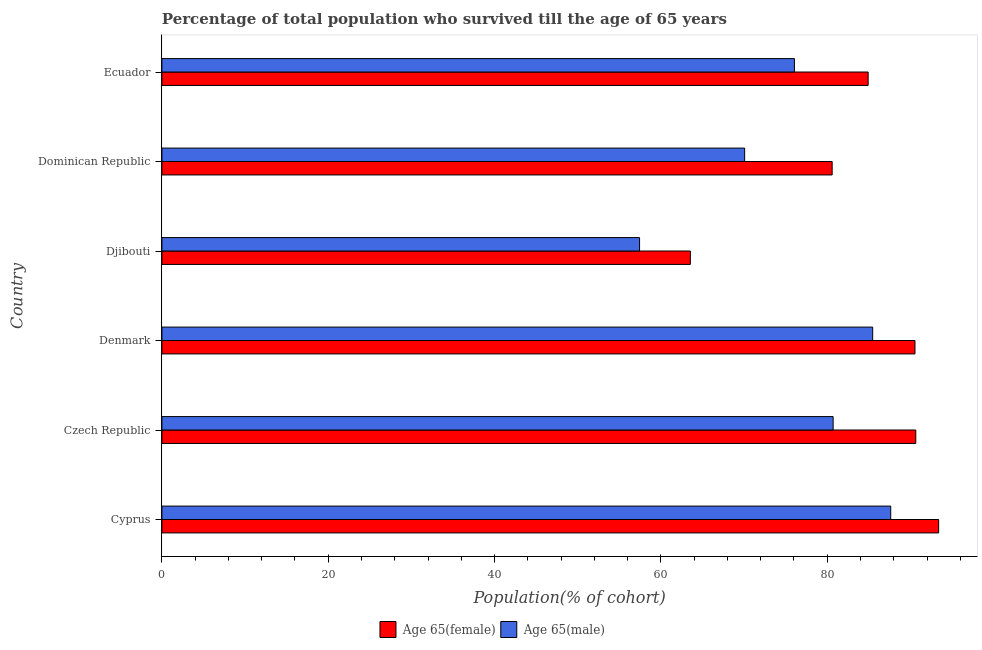How many groups of bars are there?
Provide a short and direct response. 6. Are the number of bars on each tick of the Y-axis equal?
Make the answer very short. Yes. How many bars are there on the 2nd tick from the bottom?
Your answer should be compact. 2. What is the label of the 3rd group of bars from the top?
Offer a terse response. Djibouti. In how many cases, is the number of bars for a given country not equal to the number of legend labels?
Provide a succinct answer. 0. What is the percentage of male population who survived till age of 65 in Czech Republic?
Ensure brevity in your answer.  80.71. Across all countries, what is the maximum percentage of male population who survived till age of 65?
Your answer should be very brief. 87.63. Across all countries, what is the minimum percentage of male population who survived till age of 65?
Your response must be concise. 57.43. In which country was the percentage of female population who survived till age of 65 maximum?
Offer a very short reply. Cyprus. In which country was the percentage of female population who survived till age of 65 minimum?
Your response must be concise. Djibouti. What is the total percentage of male population who survived till age of 65 in the graph?
Give a very brief answer. 457.36. What is the difference between the percentage of female population who survived till age of 65 in Cyprus and that in Dominican Republic?
Give a very brief answer. 12.8. What is the difference between the percentage of male population who survived till age of 65 in Cyprus and the percentage of female population who survived till age of 65 in Djibouti?
Provide a succinct answer. 24.09. What is the average percentage of male population who survived till age of 65 per country?
Your response must be concise. 76.23. What is the difference between the percentage of male population who survived till age of 65 and percentage of female population who survived till age of 65 in Cyprus?
Keep it short and to the point. -5.76. In how many countries, is the percentage of female population who survived till age of 65 greater than 72 %?
Give a very brief answer. 5. What is the ratio of the percentage of male population who survived till age of 65 in Cyprus to that in Dominican Republic?
Your response must be concise. 1.25. What is the difference between the highest and the second highest percentage of female population who survived till age of 65?
Your answer should be very brief. 2.75. What is the difference between the highest and the lowest percentage of male population who survived till age of 65?
Your answer should be very brief. 30.2. In how many countries, is the percentage of female population who survived till age of 65 greater than the average percentage of female population who survived till age of 65 taken over all countries?
Offer a terse response. 4. Is the sum of the percentage of female population who survived till age of 65 in Czech Republic and Dominican Republic greater than the maximum percentage of male population who survived till age of 65 across all countries?
Offer a very short reply. Yes. What does the 1st bar from the top in Ecuador represents?
Offer a terse response. Age 65(male). What does the 1st bar from the bottom in Cyprus represents?
Give a very brief answer. Age 65(female). How many bars are there?
Offer a terse response. 12. Does the graph contain any zero values?
Provide a short and direct response. No. What is the title of the graph?
Ensure brevity in your answer.  Percentage of total population who survived till the age of 65 years. Does "Commercial service imports" appear as one of the legend labels in the graph?
Make the answer very short. No. What is the label or title of the X-axis?
Keep it short and to the point. Population(% of cohort). What is the label or title of the Y-axis?
Your answer should be very brief. Country. What is the Population(% of cohort) of Age 65(female) in Cyprus?
Provide a short and direct response. 93.4. What is the Population(% of cohort) in Age 65(male) in Cyprus?
Offer a terse response. 87.63. What is the Population(% of cohort) in Age 65(female) in Czech Republic?
Your answer should be very brief. 90.65. What is the Population(% of cohort) of Age 65(male) in Czech Republic?
Make the answer very short. 80.71. What is the Population(% of cohort) in Age 65(female) in Denmark?
Provide a short and direct response. 90.55. What is the Population(% of cohort) of Age 65(male) in Denmark?
Keep it short and to the point. 85.46. What is the Population(% of cohort) in Age 65(female) in Djibouti?
Offer a terse response. 63.54. What is the Population(% of cohort) in Age 65(male) in Djibouti?
Ensure brevity in your answer.  57.43. What is the Population(% of cohort) in Age 65(female) in Dominican Republic?
Ensure brevity in your answer.  80.59. What is the Population(% of cohort) in Age 65(male) in Dominican Republic?
Your answer should be very brief. 70.07. What is the Population(% of cohort) in Age 65(female) in Ecuador?
Give a very brief answer. 84.92. What is the Population(% of cohort) of Age 65(male) in Ecuador?
Your answer should be compact. 76.05. Across all countries, what is the maximum Population(% of cohort) in Age 65(female)?
Your answer should be very brief. 93.4. Across all countries, what is the maximum Population(% of cohort) of Age 65(male)?
Your response must be concise. 87.63. Across all countries, what is the minimum Population(% of cohort) in Age 65(female)?
Keep it short and to the point. 63.54. Across all countries, what is the minimum Population(% of cohort) of Age 65(male)?
Offer a very short reply. 57.43. What is the total Population(% of cohort) of Age 65(female) in the graph?
Provide a short and direct response. 503.64. What is the total Population(% of cohort) in Age 65(male) in the graph?
Give a very brief answer. 457.36. What is the difference between the Population(% of cohort) of Age 65(female) in Cyprus and that in Czech Republic?
Provide a succinct answer. 2.75. What is the difference between the Population(% of cohort) of Age 65(male) in Cyprus and that in Czech Republic?
Ensure brevity in your answer.  6.92. What is the difference between the Population(% of cohort) in Age 65(female) in Cyprus and that in Denmark?
Your response must be concise. 2.85. What is the difference between the Population(% of cohort) of Age 65(male) in Cyprus and that in Denmark?
Make the answer very short. 2.17. What is the difference between the Population(% of cohort) of Age 65(female) in Cyprus and that in Djibouti?
Provide a succinct answer. 29.86. What is the difference between the Population(% of cohort) of Age 65(male) in Cyprus and that in Djibouti?
Ensure brevity in your answer.  30.2. What is the difference between the Population(% of cohort) in Age 65(female) in Cyprus and that in Dominican Republic?
Your answer should be compact. 12.8. What is the difference between the Population(% of cohort) of Age 65(male) in Cyprus and that in Dominican Republic?
Offer a terse response. 17.56. What is the difference between the Population(% of cohort) of Age 65(female) in Cyprus and that in Ecuador?
Provide a succinct answer. 8.48. What is the difference between the Population(% of cohort) of Age 65(male) in Cyprus and that in Ecuador?
Provide a succinct answer. 11.58. What is the difference between the Population(% of cohort) of Age 65(female) in Czech Republic and that in Denmark?
Offer a very short reply. 0.1. What is the difference between the Population(% of cohort) in Age 65(male) in Czech Republic and that in Denmark?
Give a very brief answer. -4.76. What is the difference between the Population(% of cohort) in Age 65(female) in Czech Republic and that in Djibouti?
Provide a succinct answer. 27.11. What is the difference between the Population(% of cohort) in Age 65(male) in Czech Republic and that in Djibouti?
Your response must be concise. 23.27. What is the difference between the Population(% of cohort) of Age 65(female) in Czech Republic and that in Dominican Republic?
Offer a very short reply. 10.05. What is the difference between the Population(% of cohort) of Age 65(male) in Czech Republic and that in Dominican Republic?
Your response must be concise. 10.64. What is the difference between the Population(% of cohort) of Age 65(female) in Czech Republic and that in Ecuador?
Provide a short and direct response. 5.73. What is the difference between the Population(% of cohort) of Age 65(male) in Czech Republic and that in Ecuador?
Keep it short and to the point. 4.66. What is the difference between the Population(% of cohort) in Age 65(female) in Denmark and that in Djibouti?
Offer a very short reply. 27.01. What is the difference between the Population(% of cohort) in Age 65(male) in Denmark and that in Djibouti?
Ensure brevity in your answer.  28.03. What is the difference between the Population(% of cohort) in Age 65(female) in Denmark and that in Dominican Republic?
Offer a very short reply. 9.96. What is the difference between the Population(% of cohort) in Age 65(male) in Denmark and that in Dominican Republic?
Offer a very short reply. 15.4. What is the difference between the Population(% of cohort) of Age 65(female) in Denmark and that in Ecuador?
Keep it short and to the point. 5.63. What is the difference between the Population(% of cohort) of Age 65(male) in Denmark and that in Ecuador?
Your answer should be very brief. 9.41. What is the difference between the Population(% of cohort) of Age 65(female) in Djibouti and that in Dominican Republic?
Your answer should be compact. -17.05. What is the difference between the Population(% of cohort) of Age 65(male) in Djibouti and that in Dominican Republic?
Offer a very short reply. -12.63. What is the difference between the Population(% of cohort) of Age 65(female) in Djibouti and that in Ecuador?
Your answer should be very brief. -21.38. What is the difference between the Population(% of cohort) in Age 65(male) in Djibouti and that in Ecuador?
Your answer should be very brief. -18.62. What is the difference between the Population(% of cohort) in Age 65(female) in Dominican Republic and that in Ecuador?
Keep it short and to the point. -4.33. What is the difference between the Population(% of cohort) in Age 65(male) in Dominican Republic and that in Ecuador?
Offer a terse response. -5.98. What is the difference between the Population(% of cohort) in Age 65(female) in Cyprus and the Population(% of cohort) in Age 65(male) in Czech Republic?
Offer a terse response. 12.69. What is the difference between the Population(% of cohort) in Age 65(female) in Cyprus and the Population(% of cohort) in Age 65(male) in Denmark?
Offer a very short reply. 7.93. What is the difference between the Population(% of cohort) of Age 65(female) in Cyprus and the Population(% of cohort) of Age 65(male) in Djibouti?
Provide a succinct answer. 35.96. What is the difference between the Population(% of cohort) of Age 65(female) in Cyprus and the Population(% of cohort) of Age 65(male) in Dominican Republic?
Offer a very short reply. 23.33. What is the difference between the Population(% of cohort) in Age 65(female) in Cyprus and the Population(% of cohort) in Age 65(male) in Ecuador?
Make the answer very short. 17.34. What is the difference between the Population(% of cohort) in Age 65(female) in Czech Republic and the Population(% of cohort) in Age 65(male) in Denmark?
Provide a short and direct response. 5.18. What is the difference between the Population(% of cohort) in Age 65(female) in Czech Republic and the Population(% of cohort) in Age 65(male) in Djibouti?
Your answer should be very brief. 33.21. What is the difference between the Population(% of cohort) in Age 65(female) in Czech Republic and the Population(% of cohort) in Age 65(male) in Dominican Republic?
Provide a short and direct response. 20.58. What is the difference between the Population(% of cohort) of Age 65(female) in Czech Republic and the Population(% of cohort) of Age 65(male) in Ecuador?
Provide a succinct answer. 14.59. What is the difference between the Population(% of cohort) in Age 65(female) in Denmark and the Population(% of cohort) in Age 65(male) in Djibouti?
Provide a succinct answer. 33.12. What is the difference between the Population(% of cohort) in Age 65(female) in Denmark and the Population(% of cohort) in Age 65(male) in Dominican Republic?
Your response must be concise. 20.48. What is the difference between the Population(% of cohort) of Age 65(female) in Denmark and the Population(% of cohort) of Age 65(male) in Ecuador?
Offer a very short reply. 14.5. What is the difference between the Population(% of cohort) in Age 65(female) in Djibouti and the Population(% of cohort) in Age 65(male) in Dominican Republic?
Offer a very short reply. -6.53. What is the difference between the Population(% of cohort) of Age 65(female) in Djibouti and the Population(% of cohort) of Age 65(male) in Ecuador?
Offer a terse response. -12.51. What is the difference between the Population(% of cohort) of Age 65(female) in Dominican Republic and the Population(% of cohort) of Age 65(male) in Ecuador?
Offer a very short reply. 4.54. What is the average Population(% of cohort) of Age 65(female) per country?
Your answer should be compact. 83.94. What is the average Population(% of cohort) of Age 65(male) per country?
Make the answer very short. 76.23. What is the difference between the Population(% of cohort) in Age 65(female) and Population(% of cohort) in Age 65(male) in Cyprus?
Offer a very short reply. 5.76. What is the difference between the Population(% of cohort) of Age 65(female) and Population(% of cohort) of Age 65(male) in Czech Republic?
Make the answer very short. 9.94. What is the difference between the Population(% of cohort) in Age 65(female) and Population(% of cohort) in Age 65(male) in Denmark?
Give a very brief answer. 5.09. What is the difference between the Population(% of cohort) of Age 65(female) and Population(% of cohort) of Age 65(male) in Djibouti?
Your response must be concise. 6.11. What is the difference between the Population(% of cohort) of Age 65(female) and Population(% of cohort) of Age 65(male) in Dominican Republic?
Provide a succinct answer. 10.52. What is the difference between the Population(% of cohort) of Age 65(female) and Population(% of cohort) of Age 65(male) in Ecuador?
Ensure brevity in your answer.  8.86. What is the ratio of the Population(% of cohort) of Age 65(female) in Cyprus to that in Czech Republic?
Your response must be concise. 1.03. What is the ratio of the Population(% of cohort) of Age 65(male) in Cyprus to that in Czech Republic?
Offer a very short reply. 1.09. What is the ratio of the Population(% of cohort) in Age 65(female) in Cyprus to that in Denmark?
Offer a very short reply. 1.03. What is the ratio of the Population(% of cohort) in Age 65(male) in Cyprus to that in Denmark?
Your response must be concise. 1.03. What is the ratio of the Population(% of cohort) of Age 65(female) in Cyprus to that in Djibouti?
Provide a short and direct response. 1.47. What is the ratio of the Population(% of cohort) in Age 65(male) in Cyprus to that in Djibouti?
Your answer should be compact. 1.53. What is the ratio of the Population(% of cohort) in Age 65(female) in Cyprus to that in Dominican Republic?
Your answer should be very brief. 1.16. What is the ratio of the Population(% of cohort) in Age 65(male) in Cyprus to that in Dominican Republic?
Keep it short and to the point. 1.25. What is the ratio of the Population(% of cohort) in Age 65(female) in Cyprus to that in Ecuador?
Keep it short and to the point. 1.1. What is the ratio of the Population(% of cohort) in Age 65(male) in Cyprus to that in Ecuador?
Your answer should be compact. 1.15. What is the ratio of the Population(% of cohort) in Age 65(female) in Czech Republic to that in Denmark?
Your response must be concise. 1. What is the ratio of the Population(% of cohort) of Age 65(female) in Czech Republic to that in Djibouti?
Keep it short and to the point. 1.43. What is the ratio of the Population(% of cohort) of Age 65(male) in Czech Republic to that in Djibouti?
Your response must be concise. 1.41. What is the ratio of the Population(% of cohort) in Age 65(female) in Czech Republic to that in Dominican Republic?
Offer a terse response. 1.12. What is the ratio of the Population(% of cohort) in Age 65(male) in Czech Republic to that in Dominican Republic?
Your response must be concise. 1.15. What is the ratio of the Population(% of cohort) of Age 65(female) in Czech Republic to that in Ecuador?
Offer a terse response. 1.07. What is the ratio of the Population(% of cohort) in Age 65(male) in Czech Republic to that in Ecuador?
Offer a terse response. 1.06. What is the ratio of the Population(% of cohort) of Age 65(female) in Denmark to that in Djibouti?
Your answer should be compact. 1.43. What is the ratio of the Population(% of cohort) of Age 65(male) in Denmark to that in Djibouti?
Offer a very short reply. 1.49. What is the ratio of the Population(% of cohort) of Age 65(female) in Denmark to that in Dominican Republic?
Provide a short and direct response. 1.12. What is the ratio of the Population(% of cohort) in Age 65(male) in Denmark to that in Dominican Republic?
Provide a short and direct response. 1.22. What is the ratio of the Population(% of cohort) in Age 65(female) in Denmark to that in Ecuador?
Your response must be concise. 1.07. What is the ratio of the Population(% of cohort) in Age 65(male) in Denmark to that in Ecuador?
Keep it short and to the point. 1.12. What is the ratio of the Population(% of cohort) in Age 65(female) in Djibouti to that in Dominican Republic?
Provide a succinct answer. 0.79. What is the ratio of the Population(% of cohort) in Age 65(male) in Djibouti to that in Dominican Republic?
Offer a terse response. 0.82. What is the ratio of the Population(% of cohort) of Age 65(female) in Djibouti to that in Ecuador?
Offer a terse response. 0.75. What is the ratio of the Population(% of cohort) in Age 65(male) in Djibouti to that in Ecuador?
Your answer should be compact. 0.76. What is the ratio of the Population(% of cohort) in Age 65(female) in Dominican Republic to that in Ecuador?
Keep it short and to the point. 0.95. What is the ratio of the Population(% of cohort) in Age 65(male) in Dominican Republic to that in Ecuador?
Your response must be concise. 0.92. What is the difference between the highest and the second highest Population(% of cohort) of Age 65(female)?
Your answer should be very brief. 2.75. What is the difference between the highest and the second highest Population(% of cohort) in Age 65(male)?
Provide a short and direct response. 2.17. What is the difference between the highest and the lowest Population(% of cohort) in Age 65(female)?
Ensure brevity in your answer.  29.86. What is the difference between the highest and the lowest Population(% of cohort) of Age 65(male)?
Your answer should be very brief. 30.2. 